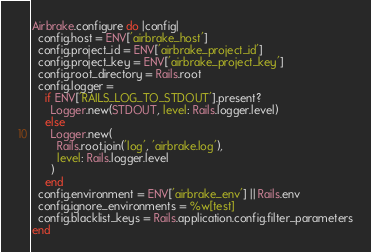<code> <loc_0><loc_0><loc_500><loc_500><_Ruby_>Airbrake.configure do |config|
  config.host = ENV['airbrake_host']
  config.project_id = ENV['airbrake_project_id']
  config.project_key = ENV['airbrake_project_key']
  config.root_directory = Rails.root
  config.logger =
    if ENV['RAILS_LOG_TO_STDOUT'].present?
      Logger.new(STDOUT, level: Rails.logger.level)
    else
      Logger.new(
        Rails.root.join('log', 'airbrake.log'),
        level: Rails.logger.level
      )
    end
  config.environment = ENV['airbrake_env'] || Rails.env
  config.ignore_environments = %w[test]
  config.blacklist_keys = Rails.application.config.filter_parameters
end
</code> 